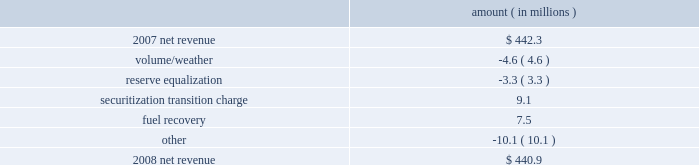Entergy texas , inc .
Management's financial discussion and analysis net revenue 2008 compared to 2007 net revenue consists of operating revenues net of : 1 ) fuel , fuel-related expenses , and gas purchased for resale , 2 ) purchased power expenses , and 3 ) other regulatory charges .
Following is an analysis of the change in net revenue comparing 2008 to 2007 .
Amount ( in millions ) .
The volume/weather variance is primarily due to decreased usage during the unbilled sales period .
See "critical accounting estimates" below and note 1 to the financial statements for further discussion of the accounting for unbilled revenues .
The reserve equalization variance is primarily due to lower reserve equalization revenue related to changes in the entergy system generation mix compared to the same period in 2007 .
The securitization transition charge variance is primarily due to the issuance of securitization bonds .
In june 2007 , entergy gulf states reconstruction funding i , a company wholly-owned and consolidated by entergy texas , issued securitization bonds and with the proceeds purchased from entergy texas the transition property , which is the right to recover from customers through a transition charge amounts sufficient to service the securitization bonds .
See note 5 to the financial statements for additional information regarding the securitization bonds .
The fuel recovery variance is primarily due to a reserve for potential rate refunds made in the first quarter 2007 as a result of a puct ruling related to the application of past puct rulings addressing transition to competition in texas .
The other variance is primarily caused by various operational effects of the jurisdictional separation on revenues and fuel and purchased power expenses .
Gross operating revenues , fuel and purchased power expenses , and other regulatory charges gross operating revenues increased $ 229.3 million primarily due to the following reasons : an increase of $ 157 million in fuel cost recovery revenues due to higher fuel rates and increased usage , partially offset by interim fuel refunds to customers for fuel cost recovery over-collections through november 2007 .
The refund was distributed over a two-month period beginning february 2008 .
The interim refund and the puct approval is discussed in note 2 to the financial statements ; an increase of $ 37.1 million in affiliated wholesale revenue primarily due to increases in the cost of energy ; an increase in transition charge amounts collected from customers to service the securitization bonds as discussed above .
See note 5 to the financial statements for additional information regarding the securitization bonds ; and implementation of an interim surcharge to collect $ 10.3 million in under-recovered incremental purchased capacity costs incurred through july 2007 .
The surcharge was collected over a two-month period beginning february 2008 .
The incremental capacity recovery rider and puct approval is discussed in note 2 to the financial statements. .
What is the growth rate in net revenue in 2008 for entergy texas , inc.? 
Computations: ((440.9 - 442.3) / 442.3)
Answer: -0.00317. 